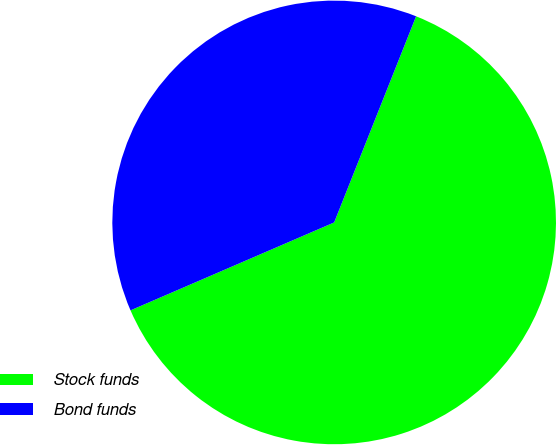<chart> <loc_0><loc_0><loc_500><loc_500><pie_chart><fcel>Stock funds<fcel>Bond funds<nl><fcel>62.49%<fcel>37.51%<nl></chart> 